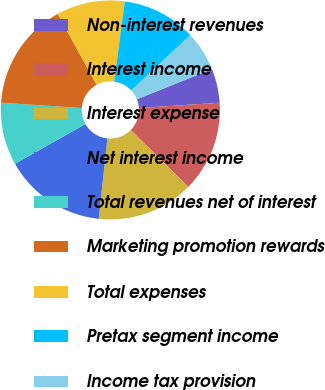<chart> <loc_0><loc_0><loc_500><loc_500><pie_chart><fcel>Non-interest revenues<fcel>Interest income<fcel>Interest expense<fcel>Net interest income<fcel>Total revenues net of interest<fcel>Marketing promotion rewards<fcel>Total expenses<fcel>Pretax segment income<fcel>Income tax provision<nl><fcel>5.04%<fcel>13.45%<fcel>14.29%<fcel>15.13%<fcel>9.24%<fcel>15.97%<fcel>10.08%<fcel>10.92%<fcel>5.88%<nl></chart> 